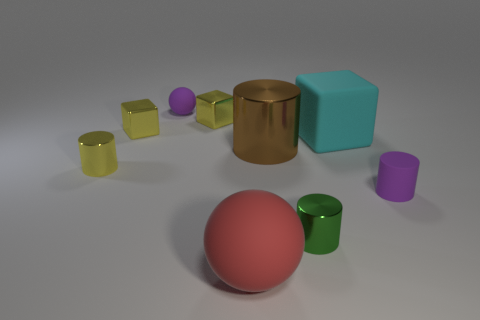What is the color of the tiny cylinder that is the same material as the small purple sphere?
Offer a terse response. Purple. Is the number of cyan blocks right of the large matte cube less than the number of purple things on the left side of the red thing?
Offer a terse response. Yes. Does the tiny shiny cylinder on the left side of the tiny purple rubber sphere have the same color as the tiny metal block to the left of the small purple rubber sphere?
Ensure brevity in your answer.  Yes. Is there a big yellow cylinder made of the same material as the purple cylinder?
Your response must be concise. No. There is a purple thing behind the tiny purple rubber object that is right of the big cyan matte object; what is its size?
Offer a terse response. Small. Is the number of purple rubber spheres greater than the number of metal cylinders?
Your response must be concise. No. Is the size of the purple object that is behind the purple cylinder the same as the red ball?
Keep it short and to the point. No. How many small blocks are the same color as the large metal cylinder?
Your response must be concise. 0. Do the green metal thing and the big cyan object have the same shape?
Your answer should be compact. No. Are there any other things that are the same size as the green object?
Offer a terse response. Yes. 